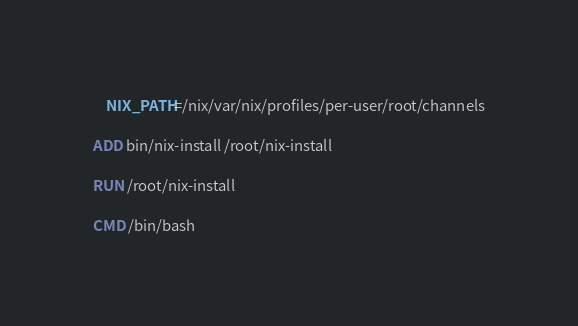Convert code to text. <code><loc_0><loc_0><loc_500><loc_500><_Dockerfile_>    NIX_PATH=/nix/var/nix/profiles/per-user/root/channels

ADD bin/nix-install /root/nix-install

RUN /root/nix-install

CMD /bin/bash

</code> 